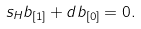Convert formula to latex. <formula><loc_0><loc_0><loc_500><loc_500>s _ { H } b _ { [ 1 ] } + d b _ { [ 0 ] } = 0 .</formula> 